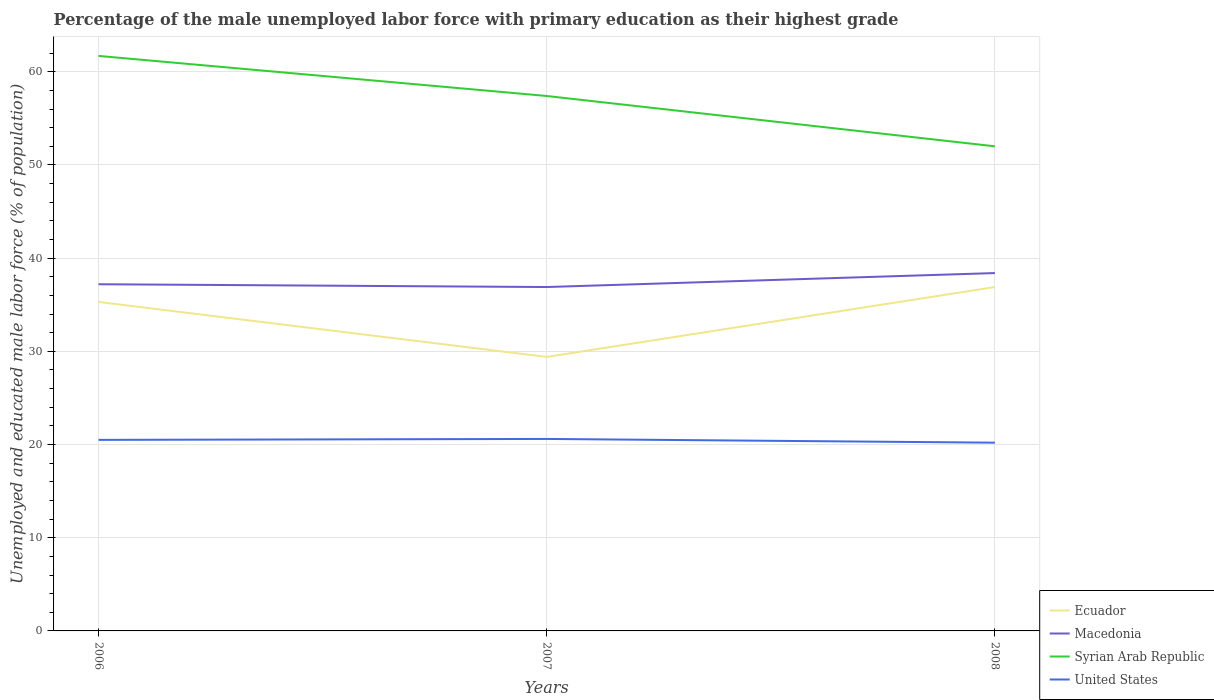Does the line corresponding to United States intersect with the line corresponding to Syrian Arab Republic?
Make the answer very short. No. Across all years, what is the maximum percentage of the unemployed male labor force with primary education in Macedonia?
Your response must be concise. 36.9. What is the total percentage of the unemployed male labor force with primary education in Macedonia in the graph?
Keep it short and to the point. -1.2. What is the difference between the highest and the second highest percentage of the unemployed male labor force with primary education in Ecuador?
Provide a short and direct response. 7.5. Is the percentage of the unemployed male labor force with primary education in Syrian Arab Republic strictly greater than the percentage of the unemployed male labor force with primary education in Ecuador over the years?
Your response must be concise. No. How many years are there in the graph?
Your answer should be very brief. 3. Are the values on the major ticks of Y-axis written in scientific E-notation?
Provide a succinct answer. No. Does the graph contain any zero values?
Your response must be concise. No. Where does the legend appear in the graph?
Offer a terse response. Bottom right. How many legend labels are there?
Ensure brevity in your answer.  4. How are the legend labels stacked?
Your answer should be compact. Vertical. What is the title of the graph?
Ensure brevity in your answer.  Percentage of the male unemployed labor force with primary education as their highest grade. What is the label or title of the X-axis?
Provide a succinct answer. Years. What is the label or title of the Y-axis?
Your answer should be very brief. Unemployed and educated male labor force (% of population). What is the Unemployed and educated male labor force (% of population) in Ecuador in 2006?
Ensure brevity in your answer.  35.3. What is the Unemployed and educated male labor force (% of population) of Macedonia in 2006?
Your answer should be compact. 37.2. What is the Unemployed and educated male labor force (% of population) in Syrian Arab Republic in 2006?
Ensure brevity in your answer.  61.7. What is the Unemployed and educated male labor force (% of population) in Ecuador in 2007?
Provide a short and direct response. 29.4. What is the Unemployed and educated male labor force (% of population) in Macedonia in 2007?
Your response must be concise. 36.9. What is the Unemployed and educated male labor force (% of population) of Syrian Arab Republic in 2007?
Provide a short and direct response. 57.4. What is the Unemployed and educated male labor force (% of population) in United States in 2007?
Your answer should be very brief. 20.6. What is the Unemployed and educated male labor force (% of population) of Ecuador in 2008?
Ensure brevity in your answer.  36.9. What is the Unemployed and educated male labor force (% of population) in Macedonia in 2008?
Your response must be concise. 38.4. What is the Unemployed and educated male labor force (% of population) in Syrian Arab Republic in 2008?
Your response must be concise. 52. What is the Unemployed and educated male labor force (% of population) in United States in 2008?
Ensure brevity in your answer.  20.2. Across all years, what is the maximum Unemployed and educated male labor force (% of population) in Ecuador?
Keep it short and to the point. 36.9. Across all years, what is the maximum Unemployed and educated male labor force (% of population) of Macedonia?
Provide a succinct answer. 38.4. Across all years, what is the maximum Unemployed and educated male labor force (% of population) in Syrian Arab Republic?
Offer a terse response. 61.7. Across all years, what is the maximum Unemployed and educated male labor force (% of population) in United States?
Your response must be concise. 20.6. Across all years, what is the minimum Unemployed and educated male labor force (% of population) of Ecuador?
Give a very brief answer. 29.4. Across all years, what is the minimum Unemployed and educated male labor force (% of population) in Macedonia?
Ensure brevity in your answer.  36.9. Across all years, what is the minimum Unemployed and educated male labor force (% of population) in Syrian Arab Republic?
Give a very brief answer. 52. Across all years, what is the minimum Unemployed and educated male labor force (% of population) of United States?
Make the answer very short. 20.2. What is the total Unemployed and educated male labor force (% of population) of Ecuador in the graph?
Ensure brevity in your answer.  101.6. What is the total Unemployed and educated male labor force (% of population) of Macedonia in the graph?
Offer a terse response. 112.5. What is the total Unemployed and educated male labor force (% of population) in Syrian Arab Republic in the graph?
Keep it short and to the point. 171.1. What is the total Unemployed and educated male labor force (% of population) of United States in the graph?
Offer a terse response. 61.3. What is the difference between the Unemployed and educated male labor force (% of population) in Ecuador in 2006 and that in 2007?
Ensure brevity in your answer.  5.9. What is the difference between the Unemployed and educated male labor force (% of population) of United States in 2006 and that in 2007?
Your answer should be very brief. -0.1. What is the difference between the Unemployed and educated male labor force (% of population) in Macedonia in 2006 and that in 2008?
Provide a succinct answer. -1.2. What is the difference between the Unemployed and educated male labor force (% of population) in Syrian Arab Republic in 2006 and that in 2008?
Your answer should be compact. 9.7. What is the difference between the Unemployed and educated male labor force (% of population) in Ecuador in 2007 and that in 2008?
Make the answer very short. -7.5. What is the difference between the Unemployed and educated male labor force (% of population) of Macedonia in 2007 and that in 2008?
Your response must be concise. -1.5. What is the difference between the Unemployed and educated male labor force (% of population) in United States in 2007 and that in 2008?
Your response must be concise. 0.4. What is the difference between the Unemployed and educated male labor force (% of population) of Ecuador in 2006 and the Unemployed and educated male labor force (% of population) of Macedonia in 2007?
Offer a terse response. -1.6. What is the difference between the Unemployed and educated male labor force (% of population) in Ecuador in 2006 and the Unemployed and educated male labor force (% of population) in Syrian Arab Republic in 2007?
Ensure brevity in your answer.  -22.1. What is the difference between the Unemployed and educated male labor force (% of population) of Macedonia in 2006 and the Unemployed and educated male labor force (% of population) of Syrian Arab Republic in 2007?
Offer a very short reply. -20.2. What is the difference between the Unemployed and educated male labor force (% of population) of Syrian Arab Republic in 2006 and the Unemployed and educated male labor force (% of population) of United States in 2007?
Ensure brevity in your answer.  41.1. What is the difference between the Unemployed and educated male labor force (% of population) of Ecuador in 2006 and the Unemployed and educated male labor force (% of population) of Syrian Arab Republic in 2008?
Provide a short and direct response. -16.7. What is the difference between the Unemployed and educated male labor force (% of population) in Ecuador in 2006 and the Unemployed and educated male labor force (% of population) in United States in 2008?
Provide a succinct answer. 15.1. What is the difference between the Unemployed and educated male labor force (% of population) of Macedonia in 2006 and the Unemployed and educated male labor force (% of population) of Syrian Arab Republic in 2008?
Provide a short and direct response. -14.8. What is the difference between the Unemployed and educated male labor force (% of population) in Syrian Arab Republic in 2006 and the Unemployed and educated male labor force (% of population) in United States in 2008?
Provide a short and direct response. 41.5. What is the difference between the Unemployed and educated male labor force (% of population) in Ecuador in 2007 and the Unemployed and educated male labor force (% of population) in Macedonia in 2008?
Offer a terse response. -9. What is the difference between the Unemployed and educated male labor force (% of population) of Ecuador in 2007 and the Unemployed and educated male labor force (% of population) of Syrian Arab Republic in 2008?
Give a very brief answer. -22.6. What is the difference between the Unemployed and educated male labor force (% of population) in Ecuador in 2007 and the Unemployed and educated male labor force (% of population) in United States in 2008?
Your answer should be compact. 9.2. What is the difference between the Unemployed and educated male labor force (% of population) of Macedonia in 2007 and the Unemployed and educated male labor force (% of population) of Syrian Arab Republic in 2008?
Provide a succinct answer. -15.1. What is the difference between the Unemployed and educated male labor force (% of population) of Syrian Arab Republic in 2007 and the Unemployed and educated male labor force (% of population) of United States in 2008?
Offer a very short reply. 37.2. What is the average Unemployed and educated male labor force (% of population) in Ecuador per year?
Make the answer very short. 33.87. What is the average Unemployed and educated male labor force (% of population) of Macedonia per year?
Keep it short and to the point. 37.5. What is the average Unemployed and educated male labor force (% of population) in Syrian Arab Republic per year?
Offer a terse response. 57.03. What is the average Unemployed and educated male labor force (% of population) of United States per year?
Offer a very short reply. 20.43. In the year 2006, what is the difference between the Unemployed and educated male labor force (% of population) in Ecuador and Unemployed and educated male labor force (% of population) in Syrian Arab Republic?
Make the answer very short. -26.4. In the year 2006, what is the difference between the Unemployed and educated male labor force (% of population) in Macedonia and Unemployed and educated male labor force (% of population) in Syrian Arab Republic?
Provide a short and direct response. -24.5. In the year 2006, what is the difference between the Unemployed and educated male labor force (% of population) in Syrian Arab Republic and Unemployed and educated male labor force (% of population) in United States?
Make the answer very short. 41.2. In the year 2007, what is the difference between the Unemployed and educated male labor force (% of population) in Ecuador and Unemployed and educated male labor force (% of population) in Macedonia?
Provide a short and direct response. -7.5. In the year 2007, what is the difference between the Unemployed and educated male labor force (% of population) of Ecuador and Unemployed and educated male labor force (% of population) of Syrian Arab Republic?
Make the answer very short. -28. In the year 2007, what is the difference between the Unemployed and educated male labor force (% of population) in Macedonia and Unemployed and educated male labor force (% of population) in Syrian Arab Republic?
Make the answer very short. -20.5. In the year 2007, what is the difference between the Unemployed and educated male labor force (% of population) in Macedonia and Unemployed and educated male labor force (% of population) in United States?
Offer a very short reply. 16.3. In the year 2007, what is the difference between the Unemployed and educated male labor force (% of population) in Syrian Arab Republic and Unemployed and educated male labor force (% of population) in United States?
Offer a terse response. 36.8. In the year 2008, what is the difference between the Unemployed and educated male labor force (% of population) of Ecuador and Unemployed and educated male labor force (% of population) of Syrian Arab Republic?
Ensure brevity in your answer.  -15.1. In the year 2008, what is the difference between the Unemployed and educated male labor force (% of population) in Macedonia and Unemployed and educated male labor force (% of population) in Syrian Arab Republic?
Ensure brevity in your answer.  -13.6. In the year 2008, what is the difference between the Unemployed and educated male labor force (% of population) of Macedonia and Unemployed and educated male labor force (% of population) of United States?
Provide a succinct answer. 18.2. In the year 2008, what is the difference between the Unemployed and educated male labor force (% of population) of Syrian Arab Republic and Unemployed and educated male labor force (% of population) of United States?
Make the answer very short. 31.8. What is the ratio of the Unemployed and educated male labor force (% of population) in Ecuador in 2006 to that in 2007?
Offer a terse response. 1.2. What is the ratio of the Unemployed and educated male labor force (% of population) of Macedonia in 2006 to that in 2007?
Your response must be concise. 1.01. What is the ratio of the Unemployed and educated male labor force (% of population) of Syrian Arab Republic in 2006 to that in 2007?
Make the answer very short. 1.07. What is the ratio of the Unemployed and educated male labor force (% of population) of United States in 2006 to that in 2007?
Provide a short and direct response. 1. What is the ratio of the Unemployed and educated male labor force (% of population) of Ecuador in 2006 to that in 2008?
Offer a very short reply. 0.96. What is the ratio of the Unemployed and educated male labor force (% of population) in Macedonia in 2006 to that in 2008?
Make the answer very short. 0.97. What is the ratio of the Unemployed and educated male labor force (% of population) in Syrian Arab Republic in 2006 to that in 2008?
Ensure brevity in your answer.  1.19. What is the ratio of the Unemployed and educated male labor force (% of population) in United States in 2006 to that in 2008?
Your answer should be very brief. 1.01. What is the ratio of the Unemployed and educated male labor force (% of population) of Ecuador in 2007 to that in 2008?
Make the answer very short. 0.8. What is the ratio of the Unemployed and educated male labor force (% of population) of Macedonia in 2007 to that in 2008?
Offer a terse response. 0.96. What is the ratio of the Unemployed and educated male labor force (% of population) of Syrian Arab Republic in 2007 to that in 2008?
Your answer should be compact. 1.1. What is the ratio of the Unemployed and educated male labor force (% of population) of United States in 2007 to that in 2008?
Ensure brevity in your answer.  1.02. What is the difference between the highest and the second highest Unemployed and educated male labor force (% of population) in Macedonia?
Make the answer very short. 1.2. 